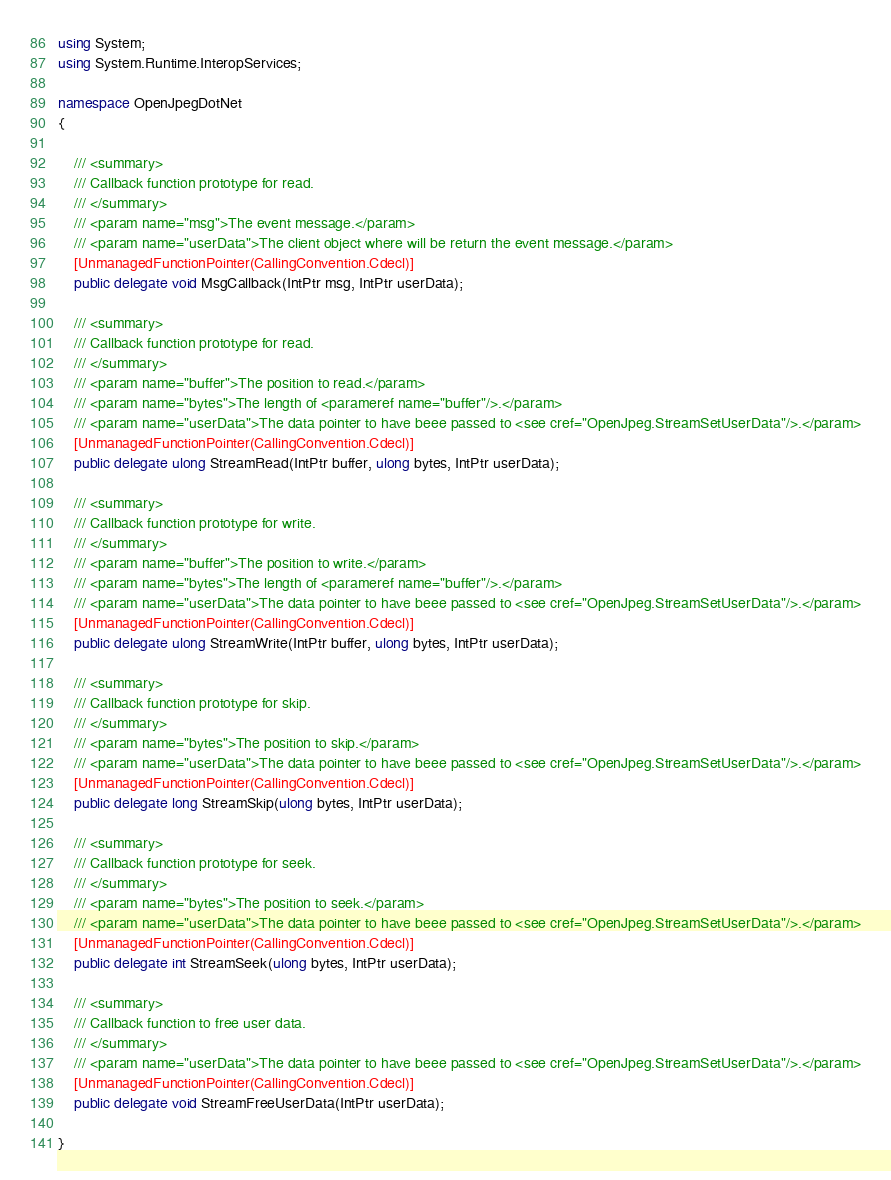<code> <loc_0><loc_0><loc_500><loc_500><_C#_>using System;
using System.Runtime.InteropServices;

namespace OpenJpegDotNet
{

    /// <summary>
    /// Callback function prototype for read.
    /// </summary>
    /// <param name="msg">The event message.</param>
    /// <param name="userData">The client object where will be return the event message.</param>
    [UnmanagedFunctionPointer(CallingConvention.Cdecl)]
    public delegate void MsgCallback(IntPtr msg, IntPtr userData);

    /// <summary>
    /// Callback function prototype for read.
    /// </summary>
    /// <param name="buffer">The position to read.</param>
    /// <param name="bytes">The length of <parameref name="buffer"/>.</param>
    /// <param name="userData">The data pointer to have beee passed to <see cref="OpenJpeg.StreamSetUserData"/>.</param>
    [UnmanagedFunctionPointer(CallingConvention.Cdecl)]
    public delegate ulong StreamRead(IntPtr buffer, ulong bytes, IntPtr userData);

    /// <summary>
    /// Callback function prototype for write.
    /// </summary>
    /// <param name="buffer">The position to write.</param>
    /// <param name="bytes">The length of <parameref name="buffer"/>.</param>
    /// <param name="userData">The data pointer to have beee passed to <see cref="OpenJpeg.StreamSetUserData"/>.</param>
    [UnmanagedFunctionPointer(CallingConvention.Cdecl)]
    public delegate ulong StreamWrite(IntPtr buffer, ulong bytes, IntPtr userData);

    /// <summary>
    /// Callback function prototype for skip.
    /// </summary>
    /// <param name="bytes">The position to skip.</param>
    /// <param name="userData">The data pointer to have beee passed to <see cref="OpenJpeg.StreamSetUserData"/>.</param>
    [UnmanagedFunctionPointer(CallingConvention.Cdecl)]
    public delegate long StreamSkip(ulong bytes, IntPtr userData);

    /// <summary>
    /// Callback function prototype for seek.
    /// </summary>
    /// <param name="bytes">The position to seek.</param>
    /// <param name="userData">The data pointer to have beee passed to <see cref="OpenJpeg.StreamSetUserData"/>.</param>
    [UnmanagedFunctionPointer(CallingConvention.Cdecl)]
    public delegate int StreamSeek(ulong bytes, IntPtr userData);

    /// <summary>
    /// Callback function to free user data.
    /// </summary>
    /// <param name="userData">The data pointer to have beee passed to <see cref="OpenJpeg.StreamSetUserData"/>.</param>
    [UnmanagedFunctionPointer(CallingConvention.Cdecl)]
    public delegate void StreamFreeUserData(IntPtr userData);

}</code> 